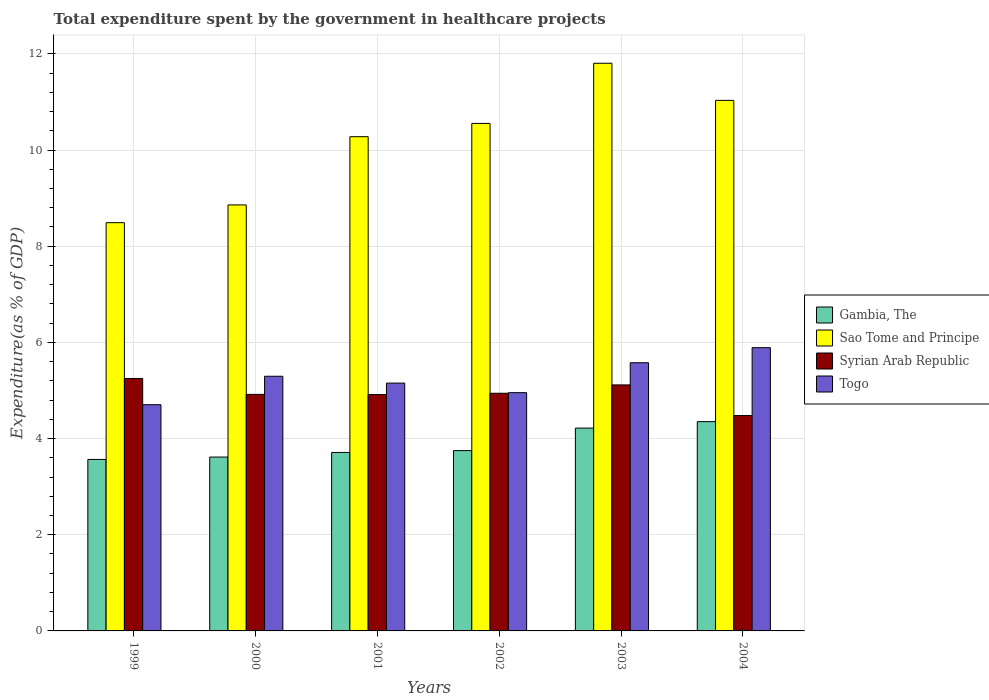How many different coloured bars are there?
Your answer should be very brief. 4. What is the label of the 2nd group of bars from the left?
Offer a terse response. 2000. What is the total expenditure spent by the government in healthcare projects in Gambia, The in 2003?
Ensure brevity in your answer.  4.22. Across all years, what is the maximum total expenditure spent by the government in healthcare projects in Syrian Arab Republic?
Your answer should be very brief. 5.25. Across all years, what is the minimum total expenditure spent by the government in healthcare projects in Sao Tome and Principe?
Keep it short and to the point. 8.49. In which year was the total expenditure spent by the government in healthcare projects in Gambia, The minimum?
Offer a terse response. 1999. What is the total total expenditure spent by the government in healthcare projects in Gambia, The in the graph?
Your answer should be compact. 23.21. What is the difference between the total expenditure spent by the government in healthcare projects in Sao Tome and Principe in 2000 and that in 2002?
Offer a very short reply. -1.7. What is the difference between the total expenditure spent by the government in healthcare projects in Gambia, The in 2003 and the total expenditure spent by the government in healthcare projects in Syrian Arab Republic in 2002?
Your response must be concise. -0.72. What is the average total expenditure spent by the government in healthcare projects in Gambia, The per year?
Your answer should be compact. 3.87. In the year 2004, what is the difference between the total expenditure spent by the government in healthcare projects in Syrian Arab Republic and total expenditure spent by the government in healthcare projects in Togo?
Ensure brevity in your answer.  -1.41. In how many years, is the total expenditure spent by the government in healthcare projects in Togo greater than 4.8 %?
Provide a succinct answer. 5. What is the ratio of the total expenditure spent by the government in healthcare projects in Syrian Arab Republic in 2000 to that in 2001?
Provide a succinct answer. 1. Is the total expenditure spent by the government in healthcare projects in Togo in 2000 less than that in 2004?
Your response must be concise. Yes. What is the difference between the highest and the second highest total expenditure spent by the government in healthcare projects in Sao Tome and Principe?
Give a very brief answer. 0.77. What is the difference between the highest and the lowest total expenditure spent by the government in healthcare projects in Sao Tome and Principe?
Provide a succinct answer. 3.32. In how many years, is the total expenditure spent by the government in healthcare projects in Syrian Arab Republic greater than the average total expenditure spent by the government in healthcare projects in Syrian Arab Republic taken over all years?
Offer a very short reply. 3. Is the sum of the total expenditure spent by the government in healthcare projects in Togo in 1999 and 2002 greater than the maximum total expenditure spent by the government in healthcare projects in Syrian Arab Republic across all years?
Your response must be concise. Yes. Is it the case that in every year, the sum of the total expenditure spent by the government in healthcare projects in Sao Tome and Principe and total expenditure spent by the government in healthcare projects in Gambia, The is greater than the sum of total expenditure spent by the government in healthcare projects in Togo and total expenditure spent by the government in healthcare projects in Syrian Arab Republic?
Make the answer very short. Yes. What does the 1st bar from the left in 2000 represents?
Your answer should be compact. Gambia, The. What does the 4th bar from the right in 2004 represents?
Provide a short and direct response. Gambia, The. Is it the case that in every year, the sum of the total expenditure spent by the government in healthcare projects in Togo and total expenditure spent by the government in healthcare projects in Gambia, The is greater than the total expenditure spent by the government in healthcare projects in Sao Tome and Principe?
Your response must be concise. No. Are all the bars in the graph horizontal?
Offer a very short reply. No. What is the difference between two consecutive major ticks on the Y-axis?
Provide a succinct answer. 2. Where does the legend appear in the graph?
Your answer should be compact. Center right. How many legend labels are there?
Offer a terse response. 4. What is the title of the graph?
Keep it short and to the point. Total expenditure spent by the government in healthcare projects. Does "Madagascar" appear as one of the legend labels in the graph?
Ensure brevity in your answer.  No. What is the label or title of the X-axis?
Ensure brevity in your answer.  Years. What is the label or title of the Y-axis?
Give a very brief answer. Expenditure(as % of GDP). What is the Expenditure(as % of GDP) in Gambia, The in 1999?
Your response must be concise. 3.57. What is the Expenditure(as % of GDP) of Sao Tome and Principe in 1999?
Offer a very short reply. 8.49. What is the Expenditure(as % of GDP) of Syrian Arab Republic in 1999?
Offer a very short reply. 5.25. What is the Expenditure(as % of GDP) in Togo in 1999?
Offer a very short reply. 4.7. What is the Expenditure(as % of GDP) of Gambia, The in 2000?
Make the answer very short. 3.62. What is the Expenditure(as % of GDP) of Sao Tome and Principe in 2000?
Offer a very short reply. 8.86. What is the Expenditure(as % of GDP) of Syrian Arab Republic in 2000?
Your answer should be very brief. 4.92. What is the Expenditure(as % of GDP) of Togo in 2000?
Provide a short and direct response. 5.3. What is the Expenditure(as % of GDP) of Gambia, The in 2001?
Offer a terse response. 3.71. What is the Expenditure(as % of GDP) of Sao Tome and Principe in 2001?
Keep it short and to the point. 10.28. What is the Expenditure(as % of GDP) in Syrian Arab Republic in 2001?
Keep it short and to the point. 4.92. What is the Expenditure(as % of GDP) of Togo in 2001?
Give a very brief answer. 5.15. What is the Expenditure(as % of GDP) in Gambia, The in 2002?
Ensure brevity in your answer.  3.75. What is the Expenditure(as % of GDP) of Sao Tome and Principe in 2002?
Provide a short and direct response. 10.55. What is the Expenditure(as % of GDP) in Syrian Arab Republic in 2002?
Your response must be concise. 4.94. What is the Expenditure(as % of GDP) of Togo in 2002?
Offer a terse response. 4.95. What is the Expenditure(as % of GDP) in Gambia, The in 2003?
Keep it short and to the point. 4.22. What is the Expenditure(as % of GDP) in Sao Tome and Principe in 2003?
Keep it short and to the point. 11.81. What is the Expenditure(as % of GDP) in Syrian Arab Republic in 2003?
Ensure brevity in your answer.  5.12. What is the Expenditure(as % of GDP) in Togo in 2003?
Make the answer very short. 5.58. What is the Expenditure(as % of GDP) of Gambia, The in 2004?
Provide a short and direct response. 4.35. What is the Expenditure(as % of GDP) in Sao Tome and Principe in 2004?
Keep it short and to the point. 11.03. What is the Expenditure(as % of GDP) of Syrian Arab Republic in 2004?
Keep it short and to the point. 4.48. What is the Expenditure(as % of GDP) in Togo in 2004?
Your answer should be compact. 5.89. Across all years, what is the maximum Expenditure(as % of GDP) in Gambia, The?
Provide a succinct answer. 4.35. Across all years, what is the maximum Expenditure(as % of GDP) in Sao Tome and Principe?
Your response must be concise. 11.81. Across all years, what is the maximum Expenditure(as % of GDP) in Syrian Arab Republic?
Your response must be concise. 5.25. Across all years, what is the maximum Expenditure(as % of GDP) in Togo?
Offer a very short reply. 5.89. Across all years, what is the minimum Expenditure(as % of GDP) in Gambia, The?
Offer a terse response. 3.57. Across all years, what is the minimum Expenditure(as % of GDP) of Sao Tome and Principe?
Make the answer very short. 8.49. Across all years, what is the minimum Expenditure(as % of GDP) in Syrian Arab Republic?
Your answer should be compact. 4.48. Across all years, what is the minimum Expenditure(as % of GDP) of Togo?
Keep it short and to the point. 4.7. What is the total Expenditure(as % of GDP) in Gambia, The in the graph?
Your answer should be compact. 23.21. What is the total Expenditure(as % of GDP) in Sao Tome and Principe in the graph?
Your answer should be compact. 61.02. What is the total Expenditure(as % of GDP) in Syrian Arab Republic in the graph?
Your answer should be compact. 29.62. What is the total Expenditure(as % of GDP) in Togo in the graph?
Offer a terse response. 31.58. What is the difference between the Expenditure(as % of GDP) in Gambia, The in 1999 and that in 2000?
Your answer should be compact. -0.05. What is the difference between the Expenditure(as % of GDP) of Sao Tome and Principe in 1999 and that in 2000?
Your answer should be very brief. -0.37. What is the difference between the Expenditure(as % of GDP) of Syrian Arab Republic in 1999 and that in 2000?
Your response must be concise. 0.33. What is the difference between the Expenditure(as % of GDP) in Togo in 1999 and that in 2000?
Offer a terse response. -0.59. What is the difference between the Expenditure(as % of GDP) of Gambia, The in 1999 and that in 2001?
Offer a terse response. -0.15. What is the difference between the Expenditure(as % of GDP) of Sao Tome and Principe in 1999 and that in 2001?
Your answer should be compact. -1.79. What is the difference between the Expenditure(as % of GDP) in Syrian Arab Republic in 1999 and that in 2001?
Your response must be concise. 0.33. What is the difference between the Expenditure(as % of GDP) in Togo in 1999 and that in 2001?
Give a very brief answer. -0.45. What is the difference between the Expenditure(as % of GDP) in Gambia, The in 1999 and that in 2002?
Offer a very short reply. -0.18. What is the difference between the Expenditure(as % of GDP) in Sao Tome and Principe in 1999 and that in 2002?
Your response must be concise. -2.06. What is the difference between the Expenditure(as % of GDP) of Syrian Arab Republic in 1999 and that in 2002?
Provide a succinct answer. 0.31. What is the difference between the Expenditure(as % of GDP) in Togo in 1999 and that in 2002?
Your answer should be very brief. -0.25. What is the difference between the Expenditure(as % of GDP) of Gambia, The in 1999 and that in 2003?
Give a very brief answer. -0.65. What is the difference between the Expenditure(as % of GDP) in Sao Tome and Principe in 1999 and that in 2003?
Provide a succinct answer. -3.32. What is the difference between the Expenditure(as % of GDP) of Syrian Arab Republic in 1999 and that in 2003?
Offer a terse response. 0.13. What is the difference between the Expenditure(as % of GDP) in Togo in 1999 and that in 2003?
Provide a succinct answer. -0.87. What is the difference between the Expenditure(as % of GDP) in Gambia, The in 1999 and that in 2004?
Your response must be concise. -0.79. What is the difference between the Expenditure(as % of GDP) in Sao Tome and Principe in 1999 and that in 2004?
Ensure brevity in your answer.  -2.54. What is the difference between the Expenditure(as % of GDP) of Syrian Arab Republic in 1999 and that in 2004?
Your response must be concise. 0.77. What is the difference between the Expenditure(as % of GDP) of Togo in 1999 and that in 2004?
Make the answer very short. -1.19. What is the difference between the Expenditure(as % of GDP) in Gambia, The in 2000 and that in 2001?
Offer a very short reply. -0.1. What is the difference between the Expenditure(as % of GDP) in Sao Tome and Principe in 2000 and that in 2001?
Provide a succinct answer. -1.42. What is the difference between the Expenditure(as % of GDP) of Syrian Arab Republic in 2000 and that in 2001?
Give a very brief answer. 0. What is the difference between the Expenditure(as % of GDP) of Togo in 2000 and that in 2001?
Provide a succinct answer. 0.14. What is the difference between the Expenditure(as % of GDP) in Gambia, The in 2000 and that in 2002?
Make the answer very short. -0.13. What is the difference between the Expenditure(as % of GDP) of Sao Tome and Principe in 2000 and that in 2002?
Your response must be concise. -1.7. What is the difference between the Expenditure(as % of GDP) of Syrian Arab Republic in 2000 and that in 2002?
Give a very brief answer. -0.02. What is the difference between the Expenditure(as % of GDP) in Togo in 2000 and that in 2002?
Your answer should be very brief. 0.34. What is the difference between the Expenditure(as % of GDP) of Gambia, The in 2000 and that in 2003?
Provide a short and direct response. -0.6. What is the difference between the Expenditure(as % of GDP) of Sao Tome and Principe in 2000 and that in 2003?
Ensure brevity in your answer.  -2.95. What is the difference between the Expenditure(as % of GDP) in Syrian Arab Republic in 2000 and that in 2003?
Give a very brief answer. -0.2. What is the difference between the Expenditure(as % of GDP) in Togo in 2000 and that in 2003?
Make the answer very short. -0.28. What is the difference between the Expenditure(as % of GDP) of Gambia, The in 2000 and that in 2004?
Make the answer very short. -0.74. What is the difference between the Expenditure(as % of GDP) in Sao Tome and Principe in 2000 and that in 2004?
Your response must be concise. -2.17. What is the difference between the Expenditure(as % of GDP) in Syrian Arab Republic in 2000 and that in 2004?
Give a very brief answer. 0.44. What is the difference between the Expenditure(as % of GDP) of Togo in 2000 and that in 2004?
Keep it short and to the point. -0.59. What is the difference between the Expenditure(as % of GDP) of Gambia, The in 2001 and that in 2002?
Keep it short and to the point. -0.04. What is the difference between the Expenditure(as % of GDP) of Sao Tome and Principe in 2001 and that in 2002?
Provide a succinct answer. -0.28. What is the difference between the Expenditure(as % of GDP) in Syrian Arab Republic in 2001 and that in 2002?
Keep it short and to the point. -0.03. What is the difference between the Expenditure(as % of GDP) in Togo in 2001 and that in 2002?
Give a very brief answer. 0.2. What is the difference between the Expenditure(as % of GDP) in Gambia, The in 2001 and that in 2003?
Your response must be concise. -0.51. What is the difference between the Expenditure(as % of GDP) in Sao Tome and Principe in 2001 and that in 2003?
Offer a terse response. -1.53. What is the difference between the Expenditure(as % of GDP) of Syrian Arab Republic in 2001 and that in 2003?
Give a very brief answer. -0.2. What is the difference between the Expenditure(as % of GDP) in Togo in 2001 and that in 2003?
Offer a terse response. -0.42. What is the difference between the Expenditure(as % of GDP) of Gambia, The in 2001 and that in 2004?
Provide a short and direct response. -0.64. What is the difference between the Expenditure(as % of GDP) in Sao Tome and Principe in 2001 and that in 2004?
Give a very brief answer. -0.76. What is the difference between the Expenditure(as % of GDP) in Syrian Arab Republic in 2001 and that in 2004?
Offer a very short reply. 0.44. What is the difference between the Expenditure(as % of GDP) in Togo in 2001 and that in 2004?
Offer a very short reply. -0.74. What is the difference between the Expenditure(as % of GDP) in Gambia, The in 2002 and that in 2003?
Your answer should be compact. -0.47. What is the difference between the Expenditure(as % of GDP) in Sao Tome and Principe in 2002 and that in 2003?
Provide a short and direct response. -1.25. What is the difference between the Expenditure(as % of GDP) of Syrian Arab Republic in 2002 and that in 2003?
Give a very brief answer. -0.17. What is the difference between the Expenditure(as % of GDP) in Togo in 2002 and that in 2003?
Make the answer very short. -0.62. What is the difference between the Expenditure(as % of GDP) in Gambia, The in 2002 and that in 2004?
Your answer should be compact. -0.6. What is the difference between the Expenditure(as % of GDP) in Sao Tome and Principe in 2002 and that in 2004?
Provide a short and direct response. -0.48. What is the difference between the Expenditure(as % of GDP) in Syrian Arab Republic in 2002 and that in 2004?
Give a very brief answer. 0.46. What is the difference between the Expenditure(as % of GDP) in Togo in 2002 and that in 2004?
Provide a succinct answer. -0.94. What is the difference between the Expenditure(as % of GDP) of Gambia, The in 2003 and that in 2004?
Your response must be concise. -0.13. What is the difference between the Expenditure(as % of GDP) in Sao Tome and Principe in 2003 and that in 2004?
Make the answer very short. 0.77. What is the difference between the Expenditure(as % of GDP) in Syrian Arab Republic in 2003 and that in 2004?
Offer a terse response. 0.64. What is the difference between the Expenditure(as % of GDP) of Togo in 2003 and that in 2004?
Provide a short and direct response. -0.31. What is the difference between the Expenditure(as % of GDP) in Gambia, The in 1999 and the Expenditure(as % of GDP) in Sao Tome and Principe in 2000?
Offer a terse response. -5.29. What is the difference between the Expenditure(as % of GDP) of Gambia, The in 1999 and the Expenditure(as % of GDP) of Syrian Arab Republic in 2000?
Provide a short and direct response. -1.35. What is the difference between the Expenditure(as % of GDP) in Gambia, The in 1999 and the Expenditure(as % of GDP) in Togo in 2000?
Your answer should be compact. -1.73. What is the difference between the Expenditure(as % of GDP) in Sao Tome and Principe in 1999 and the Expenditure(as % of GDP) in Syrian Arab Republic in 2000?
Your answer should be compact. 3.57. What is the difference between the Expenditure(as % of GDP) in Sao Tome and Principe in 1999 and the Expenditure(as % of GDP) in Togo in 2000?
Offer a terse response. 3.19. What is the difference between the Expenditure(as % of GDP) in Syrian Arab Republic in 1999 and the Expenditure(as % of GDP) in Togo in 2000?
Your answer should be very brief. -0.05. What is the difference between the Expenditure(as % of GDP) in Gambia, The in 1999 and the Expenditure(as % of GDP) in Sao Tome and Principe in 2001?
Your answer should be compact. -6.71. What is the difference between the Expenditure(as % of GDP) of Gambia, The in 1999 and the Expenditure(as % of GDP) of Syrian Arab Republic in 2001?
Make the answer very short. -1.35. What is the difference between the Expenditure(as % of GDP) in Gambia, The in 1999 and the Expenditure(as % of GDP) in Togo in 2001?
Offer a terse response. -1.59. What is the difference between the Expenditure(as % of GDP) of Sao Tome and Principe in 1999 and the Expenditure(as % of GDP) of Syrian Arab Republic in 2001?
Offer a very short reply. 3.57. What is the difference between the Expenditure(as % of GDP) of Sao Tome and Principe in 1999 and the Expenditure(as % of GDP) of Togo in 2001?
Offer a terse response. 3.34. What is the difference between the Expenditure(as % of GDP) in Syrian Arab Republic in 1999 and the Expenditure(as % of GDP) in Togo in 2001?
Give a very brief answer. 0.1. What is the difference between the Expenditure(as % of GDP) of Gambia, The in 1999 and the Expenditure(as % of GDP) of Sao Tome and Principe in 2002?
Your response must be concise. -6.99. What is the difference between the Expenditure(as % of GDP) in Gambia, The in 1999 and the Expenditure(as % of GDP) in Syrian Arab Republic in 2002?
Provide a short and direct response. -1.38. What is the difference between the Expenditure(as % of GDP) in Gambia, The in 1999 and the Expenditure(as % of GDP) in Togo in 2002?
Offer a terse response. -1.39. What is the difference between the Expenditure(as % of GDP) in Sao Tome and Principe in 1999 and the Expenditure(as % of GDP) in Syrian Arab Republic in 2002?
Make the answer very short. 3.55. What is the difference between the Expenditure(as % of GDP) in Sao Tome and Principe in 1999 and the Expenditure(as % of GDP) in Togo in 2002?
Your answer should be very brief. 3.54. What is the difference between the Expenditure(as % of GDP) in Syrian Arab Republic in 1999 and the Expenditure(as % of GDP) in Togo in 2002?
Your response must be concise. 0.29. What is the difference between the Expenditure(as % of GDP) in Gambia, The in 1999 and the Expenditure(as % of GDP) in Sao Tome and Principe in 2003?
Offer a very short reply. -8.24. What is the difference between the Expenditure(as % of GDP) in Gambia, The in 1999 and the Expenditure(as % of GDP) in Syrian Arab Republic in 2003?
Provide a short and direct response. -1.55. What is the difference between the Expenditure(as % of GDP) in Gambia, The in 1999 and the Expenditure(as % of GDP) in Togo in 2003?
Your answer should be very brief. -2.01. What is the difference between the Expenditure(as % of GDP) in Sao Tome and Principe in 1999 and the Expenditure(as % of GDP) in Syrian Arab Republic in 2003?
Give a very brief answer. 3.37. What is the difference between the Expenditure(as % of GDP) of Sao Tome and Principe in 1999 and the Expenditure(as % of GDP) of Togo in 2003?
Ensure brevity in your answer.  2.91. What is the difference between the Expenditure(as % of GDP) in Syrian Arab Republic in 1999 and the Expenditure(as % of GDP) in Togo in 2003?
Keep it short and to the point. -0.33. What is the difference between the Expenditure(as % of GDP) of Gambia, The in 1999 and the Expenditure(as % of GDP) of Sao Tome and Principe in 2004?
Your answer should be compact. -7.47. What is the difference between the Expenditure(as % of GDP) of Gambia, The in 1999 and the Expenditure(as % of GDP) of Syrian Arab Republic in 2004?
Your answer should be very brief. -0.91. What is the difference between the Expenditure(as % of GDP) in Gambia, The in 1999 and the Expenditure(as % of GDP) in Togo in 2004?
Offer a terse response. -2.32. What is the difference between the Expenditure(as % of GDP) of Sao Tome and Principe in 1999 and the Expenditure(as % of GDP) of Syrian Arab Republic in 2004?
Offer a very short reply. 4.01. What is the difference between the Expenditure(as % of GDP) of Sao Tome and Principe in 1999 and the Expenditure(as % of GDP) of Togo in 2004?
Give a very brief answer. 2.6. What is the difference between the Expenditure(as % of GDP) of Syrian Arab Republic in 1999 and the Expenditure(as % of GDP) of Togo in 2004?
Your response must be concise. -0.64. What is the difference between the Expenditure(as % of GDP) in Gambia, The in 2000 and the Expenditure(as % of GDP) in Sao Tome and Principe in 2001?
Keep it short and to the point. -6.66. What is the difference between the Expenditure(as % of GDP) in Gambia, The in 2000 and the Expenditure(as % of GDP) in Syrian Arab Republic in 2001?
Offer a terse response. -1.3. What is the difference between the Expenditure(as % of GDP) in Gambia, The in 2000 and the Expenditure(as % of GDP) in Togo in 2001?
Ensure brevity in your answer.  -1.54. What is the difference between the Expenditure(as % of GDP) of Sao Tome and Principe in 2000 and the Expenditure(as % of GDP) of Syrian Arab Republic in 2001?
Provide a succinct answer. 3.94. What is the difference between the Expenditure(as % of GDP) in Sao Tome and Principe in 2000 and the Expenditure(as % of GDP) in Togo in 2001?
Your answer should be compact. 3.71. What is the difference between the Expenditure(as % of GDP) in Syrian Arab Republic in 2000 and the Expenditure(as % of GDP) in Togo in 2001?
Provide a succinct answer. -0.23. What is the difference between the Expenditure(as % of GDP) in Gambia, The in 2000 and the Expenditure(as % of GDP) in Sao Tome and Principe in 2002?
Give a very brief answer. -6.94. What is the difference between the Expenditure(as % of GDP) in Gambia, The in 2000 and the Expenditure(as % of GDP) in Syrian Arab Republic in 2002?
Make the answer very short. -1.33. What is the difference between the Expenditure(as % of GDP) in Gambia, The in 2000 and the Expenditure(as % of GDP) in Togo in 2002?
Offer a very short reply. -1.34. What is the difference between the Expenditure(as % of GDP) of Sao Tome and Principe in 2000 and the Expenditure(as % of GDP) of Syrian Arab Republic in 2002?
Make the answer very short. 3.92. What is the difference between the Expenditure(as % of GDP) of Sao Tome and Principe in 2000 and the Expenditure(as % of GDP) of Togo in 2002?
Offer a terse response. 3.9. What is the difference between the Expenditure(as % of GDP) of Syrian Arab Republic in 2000 and the Expenditure(as % of GDP) of Togo in 2002?
Provide a short and direct response. -0.04. What is the difference between the Expenditure(as % of GDP) in Gambia, The in 2000 and the Expenditure(as % of GDP) in Sao Tome and Principe in 2003?
Offer a very short reply. -8.19. What is the difference between the Expenditure(as % of GDP) of Gambia, The in 2000 and the Expenditure(as % of GDP) of Syrian Arab Republic in 2003?
Ensure brevity in your answer.  -1.5. What is the difference between the Expenditure(as % of GDP) in Gambia, The in 2000 and the Expenditure(as % of GDP) in Togo in 2003?
Your answer should be compact. -1.96. What is the difference between the Expenditure(as % of GDP) in Sao Tome and Principe in 2000 and the Expenditure(as % of GDP) in Syrian Arab Republic in 2003?
Your response must be concise. 3.74. What is the difference between the Expenditure(as % of GDP) of Sao Tome and Principe in 2000 and the Expenditure(as % of GDP) of Togo in 2003?
Provide a succinct answer. 3.28. What is the difference between the Expenditure(as % of GDP) in Syrian Arab Republic in 2000 and the Expenditure(as % of GDP) in Togo in 2003?
Keep it short and to the point. -0.66. What is the difference between the Expenditure(as % of GDP) of Gambia, The in 2000 and the Expenditure(as % of GDP) of Sao Tome and Principe in 2004?
Provide a short and direct response. -7.42. What is the difference between the Expenditure(as % of GDP) in Gambia, The in 2000 and the Expenditure(as % of GDP) in Syrian Arab Republic in 2004?
Offer a very short reply. -0.86. What is the difference between the Expenditure(as % of GDP) of Gambia, The in 2000 and the Expenditure(as % of GDP) of Togo in 2004?
Give a very brief answer. -2.27. What is the difference between the Expenditure(as % of GDP) of Sao Tome and Principe in 2000 and the Expenditure(as % of GDP) of Syrian Arab Republic in 2004?
Make the answer very short. 4.38. What is the difference between the Expenditure(as % of GDP) of Sao Tome and Principe in 2000 and the Expenditure(as % of GDP) of Togo in 2004?
Your response must be concise. 2.97. What is the difference between the Expenditure(as % of GDP) in Syrian Arab Republic in 2000 and the Expenditure(as % of GDP) in Togo in 2004?
Provide a succinct answer. -0.97. What is the difference between the Expenditure(as % of GDP) of Gambia, The in 2001 and the Expenditure(as % of GDP) of Sao Tome and Principe in 2002?
Your answer should be compact. -6.84. What is the difference between the Expenditure(as % of GDP) in Gambia, The in 2001 and the Expenditure(as % of GDP) in Syrian Arab Republic in 2002?
Keep it short and to the point. -1.23. What is the difference between the Expenditure(as % of GDP) of Gambia, The in 2001 and the Expenditure(as % of GDP) of Togo in 2002?
Offer a very short reply. -1.24. What is the difference between the Expenditure(as % of GDP) in Sao Tome and Principe in 2001 and the Expenditure(as % of GDP) in Syrian Arab Republic in 2002?
Your answer should be very brief. 5.34. What is the difference between the Expenditure(as % of GDP) in Sao Tome and Principe in 2001 and the Expenditure(as % of GDP) in Togo in 2002?
Your answer should be compact. 5.32. What is the difference between the Expenditure(as % of GDP) in Syrian Arab Republic in 2001 and the Expenditure(as % of GDP) in Togo in 2002?
Your answer should be very brief. -0.04. What is the difference between the Expenditure(as % of GDP) in Gambia, The in 2001 and the Expenditure(as % of GDP) in Sao Tome and Principe in 2003?
Offer a very short reply. -8.09. What is the difference between the Expenditure(as % of GDP) of Gambia, The in 2001 and the Expenditure(as % of GDP) of Syrian Arab Republic in 2003?
Keep it short and to the point. -1.4. What is the difference between the Expenditure(as % of GDP) of Gambia, The in 2001 and the Expenditure(as % of GDP) of Togo in 2003?
Keep it short and to the point. -1.87. What is the difference between the Expenditure(as % of GDP) of Sao Tome and Principe in 2001 and the Expenditure(as % of GDP) of Syrian Arab Republic in 2003?
Provide a succinct answer. 5.16. What is the difference between the Expenditure(as % of GDP) in Sao Tome and Principe in 2001 and the Expenditure(as % of GDP) in Togo in 2003?
Your answer should be compact. 4.7. What is the difference between the Expenditure(as % of GDP) in Syrian Arab Republic in 2001 and the Expenditure(as % of GDP) in Togo in 2003?
Offer a terse response. -0.66. What is the difference between the Expenditure(as % of GDP) in Gambia, The in 2001 and the Expenditure(as % of GDP) in Sao Tome and Principe in 2004?
Give a very brief answer. -7.32. What is the difference between the Expenditure(as % of GDP) of Gambia, The in 2001 and the Expenditure(as % of GDP) of Syrian Arab Republic in 2004?
Your answer should be very brief. -0.77. What is the difference between the Expenditure(as % of GDP) in Gambia, The in 2001 and the Expenditure(as % of GDP) in Togo in 2004?
Make the answer very short. -2.18. What is the difference between the Expenditure(as % of GDP) of Sao Tome and Principe in 2001 and the Expenditure(as % of GDP) of Syrian Arab Republic in 2004?
Keep it short and to the point. 5.8. What is the difference between the Expenditure(as % of GDP) of Sao Tome and Principe in 2001 and the Expenditure(as % of GDP) of Togo in 2004?
Provide a short and direct response. 4.39. What is the difference between the Expenditure(as % of GDP) in Syrian Arab Republic in 2001 and the Expenditure(as % of GDP) in Togo in 2004?
Make the answer very short. -0.98. What is the difference between the Expenditure(as % of GDP) in Gambia, The in 2002 and the Expenditure(as % of GDP) in Sao Tome and Principe in 2003?
Provide a short and direct response. -8.06. What is the difference between the Expenditure(as % of GDP) of Gambia, The in 2002 and the Expenditure(as % of GDP) of Syrian Arab Republic in 2003?
Your response must be concise. -1.37. What is the difference between the Expenditure(as % of GDP) of Gambia, The in 2002 and the Expenditure(as % of GDP) of Togo in 2003?
Ensure brevity in your answer.  -1.83. What is the difference between the Expenditure(as % of GDP) of Sao Tome and Principe in 2002 and the Expenditure(as % of GDP) of Syrian Arab Republic in 2003?
Your answer should be compact. 5.44. What is the difference between the Expenditure(as % of GDP) in Sao Tome and Principe in 2002 and the Expenditure(as % of GDP) in Togo in 2003?
Keep it short and to the point. 4.98. What is the difference between the Expenditure(as % of GDP) of Syrian Arab Republic in 2002 and the Expenditure(as % of GDP) of Togo in 2003?
Offer a terse response. -0.63. What is the difference between the Expenditure(as % of GDP) of Gambia, The in 2002 and the Expenditure(as % of GDP) of Sao Tome and Principe in 2004?
Provide a short and direct response. -7.28. What is the difference between the Expenditure(as % of GDP) of Gambia, The in 2002 and the Expenditure(as % of GDP) of Syrian Arab Republic in 2004?
Ensure brevity in your answer.  -0.73. What is the difference between the Expenditure(as % of GDP) of Gambia, The in 2002 and the Expenditure(as % of GDP) of Togo in 2004?
Offer a very short reply. -2.14. What is the difference between the Expenditure(as % of GDP) in Sao Tome and Principe in 2002 and the Expenditure(as % of GDP) in Syrian Arab Republic in 2004?
Provide a succinct answer. 6.08. What is the difference between the Expenditure(as % of GDP) of Sao Tome and Principe in 2002 and the Expenditure(as % of GDP) of Togo in 2004?
Your answer should be compact. 4.66. What is the difference between the Expenditure(as % of GDP) of Syrian Arab Republic in 2002 and the Expenditure(as % of GDP) of Togo in 2004?
Your answer should be compact. -0.95. What is the difference between the Expenditure(as % of GDP) in Gambia, The in 2003 and the Expenditure(as % of GDP) in Sao Tome and Principe in 2004?
Keep it short and to the point. -6.82. What is the difference between the Expenditure(as % of GDP) of Gambia, The in 2003 and the Expenditure(as % of GDP) of Syrian Arab Republic in 2004?
Keep it short and to the point. -0.26. What is the difference between the Expenditure(as % of GDP) in Gambia, The in 2003 and the Expenditure(as % of GDP) in Togo in 2004?
Offer a very short reply. -1.67. What is the difference between the Expenditure(as % of GDP) of Sao Tome and Principe in 2003 and the Expenditure(as % of GDP) of Syrian Arab Republic in 2004?
Your response must be concise. 7.33. What is the difference between the Expenditure(as % of GDP) of Sao Tome and Principe in 2003 and the Expenditure(as % of GDP) of Togo in 2004?
Your answer should be compact. 5.91. What is the difference between the Expenditure(as % of GDP) of Syrian Arab Republic in 2003 and the Expenditure(as % of GDP) of Togo in 2004?
Your response must be concise. -0.77. What is the average Expenditure(as % of GDP) in Gambia, The per year?
Offer a very short reply. 3.87. What is the average Expenditure(as % of GDP) of Sao Tome and Principe per year?
Make the answer very short. 10.17. What is the average Expenditure(as % of GDP) of Syrian Arab Republic per year?
Your answer should be compact. 4.94. What is the average Expenditure(as % of GDP) of Togo per year?
Give a very brief answer. 5.26. In the year 1999, what is the difference between the Expenditure(as % of GDP) of Gambia, The and Expenditure(as % of GDP) of Sao Tome and Principe?
Offer a terse response. -4.92. In the year 1999, what is the difference between the Expenditure(as % of GDP) in Gambia, The and Expenditure(as % of GDP) in Syrian Arab Republic?
Provide a succinct answer. -1.68. In the year 1999, what is the difference between the Expenditure(as % of GDP) in Gambia, The and Expenditure(as % of GDP) in Togo?
Your answer should be compact. -1.14. In the year 1999, what is the difference between the Expenditure(as % of GDP) of Sao Tome and Principe and Expenditure(as % of GDP) of Syrian Arab Republic?
Your answer should be compact. 3.24. In the year 1999, what is the difference between the Expenditure(as % of GDP) in Sao Tome and Principe and Expenditure(as % of GDP) in Togo?
Your answer should be compact. 3.79. In the year 1999, what is the difference between the Expenditure(as % of GDP) of Syrian Arab Republic and Expenditure(as % of GDP) of Togo?
Your answer should be compact. 0.55. In the year 2000, what is the difference between the Expenditure(as % of GDP) in Gambia, The and Expenditure(as % of GDP) in Sao Tome and Principe?
Offer a very short reply. -5.24. In the year 2000, what is the difference between the Expenditure(as % of GDP) of Gambia, The and Expenditure(as % of GDP) of Syrian Arab Republic?
Your response must be concise. -1.3. In the year 2000, what is the difference between the Expenditure(as % of GDP) of Gambia, The and Expenditure(as % of GDP) of Togo?
Your answer should be very brief. -1.68. In the year 2000, what is the difference between the Expenditure(as % of GDP) in Sao Tome and Principe and Expenditure(as % of GDP) in Syrian Arab Republic?
Your answer should be very brief. 3.94. In the year 2000, what is the difference between the Expenditure(as % of GDP) of Sao Tome and Principe and Expenditure(as % of GDP) of Togo?
Ensure brevity in your answer.  3.56. In the year 2000, what is the difference between the Expenditure(as % of GDP) in Syrian Arab Republic and Expenditure(as % of GDP) in Togo?
Give a very brief answer. -0.38. In the year 2001, what is the difference between the Expenditure(as % of GDP) in Gambia, The and Expenditure(as % of GDP) in Sao Tome and Principe?
Make the answer very short. -6.57. In the year 2001, what is the difference between the Expenditure(as % of GDP) in Gambia, The and Expenditure(as % of GDP) in Syrian Arab Republic?
Your answer should be very brief. -1.2. In the year 2001, what is the difference between the Expenditure(as % of GDP) in Gambia, The and Expenditure(as % of GDP) in Togo?
Provide a succinct answer. -1.44. In the year 2001, what is the difference between the Expenditure(as % of GDP) of Sao Tome and Principe and Expenditure(as % of GDP) of Syrian Arab Republic?
Offer a terse response. 5.36. In the year 2001, what is the difference between the Expenditure(as % of GDP) of Sao Tome and Principe and Expenditure(as % of GDP) of Togo?
Give a very brief answer. 5.12. In the year 2001, what is the difference between the Expenditure(as % of GDP) in Syrian Arab Republic and Expenditure(as % of GDP) in Togo?
Make the answer very short. -0.24. In the year 2002, what is the difference between the Expenditure(as % of GDP) of Gambia, The and Expenditure(as % of GDP) of Sao Tome and Principe?
Your answer should be compact. -6.8. In the year 2002, what is the difference between the Expenditure(as % of GDP) in Gambia, The and Expenditure(as % of GDP) in Syrian Arab Republic?
Offer a terse response. -1.19. In the year 2002, what is the difference between the Expenditure(as % of GDP) of Gambia, The and Expenditure(as % of GDP) of Togo?
Your answer should be compact. -1.2. In the year 2002, what is the difference between the Expenditure(as % of GDP) in Sao Tome and Principe and Expenditure(as % of GDP) in Syrian Arab Republic?
Make the answer very short. 5.61. In the year 2002, what is the difference between the Expenditure(as % of GDP) of Sao Tome and Principe and Expenditure(as % of GDP) of Togo?
Offer a terse response. 5.6. In the year 2002, what is the difference between the Expenditure(as % of GDP) of Syrian Arab Republic and Expenditure(as % of GDP) of Togo?
Offer a terse response. -0.01. In the year 2003, what is the difference between the Expenditure(as % of GDP) in Gambia, The and Expenditure(as % of GDP) in Sao Tome and Principe?
Your answer should be compact. -7.59. In the year 2003, what is the difference between the Expenditure(as % of GDP) of Gambia, The and Expenditure(as % of GDP) of Syrian Arab Republic?
Give a very brief answer. -0.9. In the year 2003, what is the difference between the Expenditure(as % of GDP) of Gambia, The and Expenditure(as % of GDP) of Togo?
Offer a terse response. -1.36. In the year 2003, what is the difference between the Expenditure(as % of GDP) in Sao Tome and Principe and Expenditure(as % of GDP) in Syrian Arab Republic?
Provide a short and direct response. 6.69. In the year 2003, what is the difference between the Expenditure(as % of GDP) of Sao Tome and Principe and Expenditure(as % of GDP) of Togo?
Keep it short and to the point. 6.23. In the year 2003, what is the difference between the Expenditure(as % of GDP) in Syrian Arab Republic and Expenditure(as % of GDP) in Togo?
Your answer should be compact. -0.46. In the year 2004, what is the difference between the Expenditure(as % of GDP) of Gambia, The and Expenditure(as % of GDP) of Sao Tome and Principe?
Ensure brevity in your answer.  -6.68. In the year 2004, what is the difference between the Expenditure(as % of GDP) in Gambia, The and Expenditure(as % of GDP) in Syrian Arab Republic?
Keep it short and to the point. -0.13. In the year 2004, what is the difference between the Expenditure(as % of GDP) in Gambia, The and Expenditure(as % of GDP) in Togo?
Ensure brevity in your answer.  -1.54. In the year 2004, what is the difference between the Expenditure(as % of GDP) of Sao Tome and Principe and Expenditure(as % of GDP) of Syrian Arab Republic?
Your response must be concise. 6.55. In the year 2004, what is the difference between the Expenditure(as % of GDP) in Sao Tome and Principe and Expenditure(as % of GDP) in Togo?
Give a very brief answer. 5.14. In the year 2004, what is the difference between the Expenditure(as % of GDP) of Syrian Arab Republic and Expenditure(as % of GDP) of Togo?
Ensure brevity in your answer.  -1.41. What is the ratio of the Expenditure(as % of GDP) in Gambia, The in 1999 to that in 2000?
Your answer should be compact. 0.99. What is the ratio of the Expenditure(as % of GDP) in Sao Tome and Principe in 1999 to that in 2000?
Offer a terse response. 0.96. What is the ratio of the Expenditure(as % of GDP) of Syrian Arab Republic in 1999 to that in 2000?
Ensure brevity in your answer.  1.07. What is the ratio of the Expenditure(as % of GDP) in Togo in 1999 to that in 2000?
Provide a short and direct response. 0.89. What is the ratio of the Expenditure(as % of GDP) in Gambia, The in 1999 to that in 2001?
Your response must be concise. 0.96. What is the ratio of the Expenditure(as % of GDP) in Sao Tome and Principe in 1999 to that in 2001?
Your answer should be very brief. 0.83. What is the ratio of the Expenditure(as % of GDP) of Syrian Arab Republic in 1999 to that in 2001?
Make the answer very short. 1.07. What is the ratio of the Expenditure(as % of GDP) of Togo in 1999 to that in 2001?
Offer a terse response. 0.91. What is the ratio of the Expenditure(as % of GDP) of Gambia, The in 1999 to that in 2002?
Keep it short and to the point. 0.95. What is the ratio of the Expenditure(as % of GDP) in Sao Tome and Principe in 1999 to that in 2002?
Offer a terse response. 0.8. What is the ratio of the Expenditure(as % of GDP) of Syrian Arab Republic in 1999 to that in 2002?
Provide a succinct answer. 1.06. What is the ratio of the Expenditure(as % of GDP) of Togo in 1999 to that in 2002?
Ensure brevity in your answer.  0.95. What is the ratio of the Expenditure(as % of GDP) in Gambia, The in 1999 to that in 2003?
Your response must be concise. 0.85. What is the ratio of the Expenditure(as % of GDP) in Sao Tome and Principe in 1999 to that in 2003?
Make the answer very short. 0.72. What is the ratio of the Expenditure(as % of GDP) in Syrian Arab Republic in 1999 to that in 2003?
Your answer should be very brief. 1.03. What is the ratio of the Expenditure(as % of GDP) in Togo in 1999 to that in 2003?
Make the answer very short. 0.84. What is the ratio of the Expenditure(as % of GDP) of Gambia, The in 1999 to that in 2004?
Provide a succinct answer. 0.82. What is the ratio of the Expenditure(as % of GDP) in Sao Tome and Principe in 1999 to that in 2004?
Keep it short and to the point. 0.77. What is the ratio of the Expenditure(as % of GDP) in Syrian Arab Republic in 1999 to that in 2004?
Offer a terse response. 1.17. What is the ratio of the Expenditure(as % of GDP) in Togo in 1999 to that in 2004?
Give a very brief answer. 0.8. What is the ratio of the Expenditure(as % of GDP) in Gambia, The in 2000 to that in 2001?
Keep it short and to the point. 0.97. What is the ratio of the Expenditure(as % of GDP) of Sao Tome and Principe in 2000 to that in 2001?
Your answer should be compact. 0.86. What is the ratio of the Expenditure(as % of GDP) of Togo in 2000 to that in 2001?
Ensure brevity in your answer.  1.03. What is the ratio of the Expenditure(as % of GDP) in Gambia, The in 2000 to that in 2002?
Provide a succinct answer. 0.96. What is the ratio of the Expenditure(as % of GDP) in Sao Tome and Principe in 2000 to that in 2002?
Make the answer very short. 0.84. What is the ratio of the Expenditure(as % of GDP) in Togo in 2000 to that in 2002?
Ensure brevity in your answer.  1.07. What is the ratio of the Expenditure(as % of GDP) of Gambia, The in 2000 to that in 2003?
Make the answer very short. 0.86. What is the ratio of the Expenditure(as % of GDP) in Sao Tome and Principe in 2000 to that in 2003?
Your response must be concise. 0.75. What is the ratio of the Expenditure(as % of GDP) in Syrian Arab Republic in 2000 to that in 2003?
Keep it short and to the point. 0.96. What is the ratio of the Expenditure(as % of GDP) in Togo in 2000 to that in 2003?
Offer a very short reply. 0.95. What is the ratio of the Expenditure(as % of GDP) in Gambia, The in 2000 to that in 2004?
Your answer should be very brief. 0.83. What is the ratio of the Expenditure(as % of GDP) of Sao Tome and Principe in 2000 to that in 2004?
Your answer should be compact. 0.8. What is the ratio of the Expenditure(as % of GDP) in Syrian Arab Republic in 2000 to that in 2004?
Make the answer very short. 1.1. What is the ratio of the Expenditure(as % of GDP) in Togo in 2000 to that in 2004?
Provide a short and direct response. 0.9. What is the ratio of the Expenditure(as % of GDP) of Gambia, The in 2001 to that in 2002?
Your answer should be compact. 0.99. What is the ratio of the Expenditure(as % of GDP) of Sao Tome and Principe in 2001 to that in 2002?
Provide a short and direct response. 0.97. What is the ratio of the Expenditure(as % of GDP) in Syrian Arab Republic in 2001 to that in 2002?
Provide a short and direct response. 0.99. What is the ratio of the Expenditure(as % of GDP) of Togo in 2001 to that in 2002?
Your answer should be compact. 1.04. What is the ratio of the Expenditure(as % of GDP) in Gambia, The in 2001 to that in 2003?
Make the answer very short. 0.88. What is the ratio of the Expenditure(as % of GDP) in Sao Tome and Principe in 2001 to that in 2003?
Make the answer very short. 0.87. What is the ratio of the Expenditure(as % of GDP) in Syrian Arab Republic in 2001 to that in 2003?
Give a very brief answer. 0.96. What is the ratio of the Expenditure(as % of GDP) in Togo in 2001 to that in 2003?
Offer a terse response. 0.92. What is the ratio of the Expenditure(as % of GDP) in Gambia, The in 2001 to that in 2004?
Ensure brevity in your answer.  0.85. What is the ratio of the Expenditure(as % of GDP) of Sao Tome and Principe in 2001 to that in 2004?
Keep it short and to the point. 0.93. What is the ratio of the Expenditure(as % of GDP) in Syrian Arab Republic in 2001 to that in 2004?
Offer a terse response. 1.1. What is the ratio of the Expenditure(as % of GDP) in Togo in 2001 to that in 2004?
Your answer should be compact. 0.87. What is the ratio of the Expenditure(as % of GDP) of Gambia, The in 2002 to that in 2003?
Your answer should be compact. 0.89. What is the ratio of the Expenditure(as % of GDP) in Sao Tome and Principe in 2002 to that in 2003?
Your answer should be very brief. 0.89. What is the ratio of the Expenditure(as % of GDP) in Syrian Arab Republic in 2002 to that in 2003?
Provide a short and direct response. 0.97. What is the ratio of the Expenditure(as % of GDP) in Togo in 2002 to that in 2003?
Provide a succinct answer. 0.89. What is the ratio of the Expenditure(as % of GDP) of Gambia, The in 2002 to that in 2004?
Your response must be concise. 0.86. What is the ratio of the Expenditure(as % of GDP) in Sao Tome and Principe in 2002 to that in 2004?
Keep it short and to the point. 0.96. What is the ratio of the Expenditure(as % of GDP) of Syrian Arab Republic in 2002 to that in 2004?
Offer a very short reply. 1.1. What is the ratio of the Expenditure(as % of GDP) of Togo in 2002 to that in 2004?
Your response must be concise. 0.84. What is the ratio of the Expenditure(as % of GDP) of Gambia, The in 2003 to that in 2004?
Provide a short and direct response. 0.97. What is the ratio of the Expenditure(as % of GDP) in Sao Tome and Principe in 2003 to that in 2004?
Provide a short and direct response. 1.07. What is the ratio of the Expenditure(as % of GDP) in Syrian Arab Republic in 2003 to that in 2004?
Give a very brief answer. 1.14. What is the ratio of the Expenditure(as % of GDP) of Togo in 2003 to that in 2004?
Your answer should be compact. 0.95. What is the difference between the highest and the second highest Expenditure(as % of GDP) in Gambia, The?
Offer a very short reply. 0.13. What is the difference between the highest and the second highest Expenditure(as % of GDP) in Sao Tome and Principe?
Offer a very short reply. 0.77. What is the difference between the highest and the second highest Expenditure(as % of GDP) of Syrian Arab Republic?
Your answer should be very brief. 0.13. What is the difference between the highest and the second highest Expenditure(as % of GDP) of Togo?
Keep it short and to the point. 0.31. What is the difference between the highest and the lowest Expenditure(as % of GDP) in Gambia, The?
Your response must be concise. 0.79. What is the difference between the highest and the lowest Expenditure(as % of GDP) in Sao Tome and Principe?
Provide a succinct answer. 3.32. What is the difference between the highest and the lowest Expenditure(as % of GDP) of Syrian Arab Republic?
Provide a short and direct response. 0.77. What is the difference between the highest and the lowest Expenditure(as % of GDP) in Togo?
Provide a succinct answer. 1.19. 